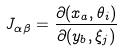Convert formula to latex. <formula><loc_0><loc_0><loc_500><loc_500>J _ { \alpha \beta } = \frac { \partial ( x _ { a } , \theta _ { i } ) } { \partial ( y _ { b } , \xi _ { j } ) }</formula> 